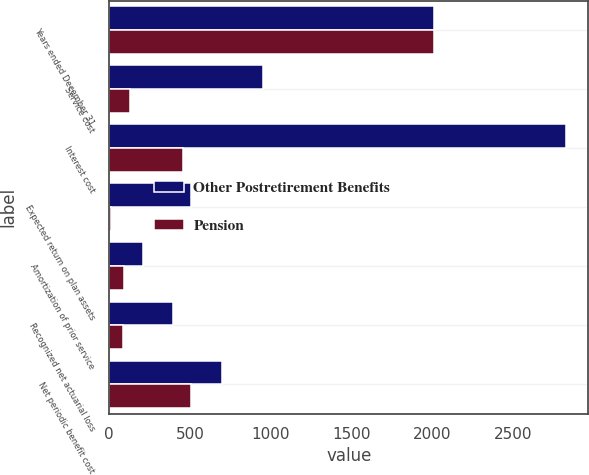<chart> <loc_0><loc_0><loc_500><loc_500><stacked_bar_chart><ecel><fcel>Years ended December 31<fcel>Service cost<fcel>Interest cost<fcel>Expected return on plan assets<fcel>Amortization of prior service<fcel>Recognized net actuarial loss<fcel>Net periodic benefit cost<nl><fcel>Other Postretirement Benefits<fcel>2008<fcel>952<fcel>2823<fcel>507<fcel>206<fcel>392<fcel>696<nl><fcel>Pension<fcel>2008<fcel>126<fcel>459<fcel>8<fcel>93<fcel>86<fcel>507<nl></chart> 